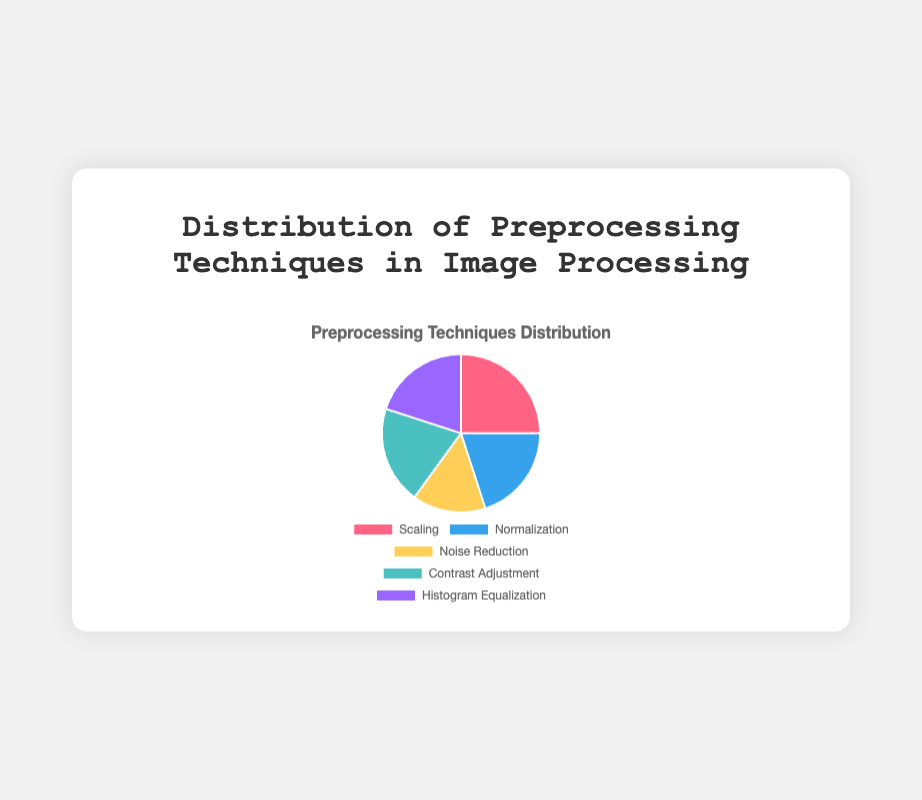How many preprocessing techniques each have a 20% distribution? Look at the pie chart legend or labels. Techniques with 20% are Normalization, Contrast Adjustment, and Histogram Equalization. Count them.
Answer: 3 Which technique is used the most in image processing studies? Refer to the percentage values in the pie chart. The highest percentage is 25%, which corresponds to Scaling.
Answer: Scaling What is the combined percentage of Normalization and Noise Reduction? Sum the percentages of Normalization (20%) and Noise Reduction (15%). 20% + 15% = 35%
Answer: 35% Which preprocessing technique has the smallest percentage share but is still used in image processing studies? Compare all the percentage shares; the smallest one is 15%. Identify the corresponding technique, which is Noise Reduction.
Answer: Noise Reduction Is the percentage share of Contrast Adjustment equal to that of Histogram Equalization? Compare the percentages for Contrast Adjustment and Histogram Equalization, both of which are 20%.
Answer: Yes What color represents Noise Reduction in the pie chart? Identify the color segment in the pie chart for Noise Reduction. The color assigned to Noise Reduction is yellow.
Answer: yellow What is the average percentage of all preprocessing techniques used? Calculate the average of the percentages: (25% + 20% + 15% + 20% + 20%) / 5 = 20%.
Answer: 20% Which color corresponds to the technique used least frequently? Identify the segment with the smallest percentage (Noise Reduction) and its color (yellow).
Answer: yellow How many techniques have a distribution greater than or equal to 20%? Identify techniques with percentages of 20% or greater: Scaling (25%), Normalization (20%), Contrast Adjustment (20%), Histogram Equalization (20%). Count them.
Answer: 4 Which technique has a percentage share closest to the overall average percentage? Calculate the average percentage (20%). Compare each technique’s percentage to find the closest, which are Normalization, Contrast Adjustment, and Histogram Equalization, all with exactly 20%.
Answer: Normalization, Contrast Adjustment, Histogram Equalization 